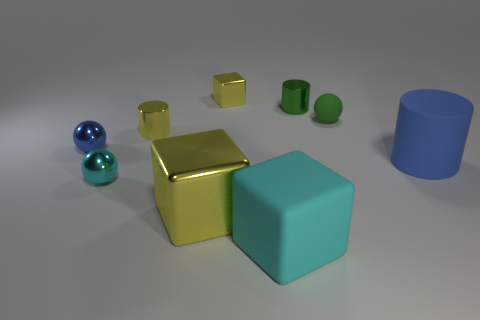There is a small sphere that is in front of the blue thing on the left side of the large matte thing behind the cyan rubber object; what is its color?
Your answer should be compact. Cyan. There is a blue object that is the same size as the matte block; what is its shape?
Offer a terse response. Cylinder. Is the number of small spheres greater than the number of cyan metallic balls?
Offer a very short reply. Yes. There is a small yellow shiny thing that is in front of the small metallic block; is there a object behind it?
Offer a terse response. Yes. The other matte thing that is the same shape as the small cyan thing is what color?
Provide a succinct answer. Green. Is there any other thing that has the same shape as the green metal thing?
Offer a very short reply. Yes. What color is the other cylinder that is the same material as the tiny yellow cylinder?
Offer a terse response. Green. Are there any green cylinders on the left side of the blue object that is to the left of the large matte object on the right side of the rubber ball?
Your answer should be compact. No. Is the number of green balls that are behind the green shiny thing less than the number of small balls to the left of the cyan matte thing?
Offer a very short reply. Yes. What number of tiny blue things have the same material as the blue cylinder?
Keep it short and to the point. 0. 